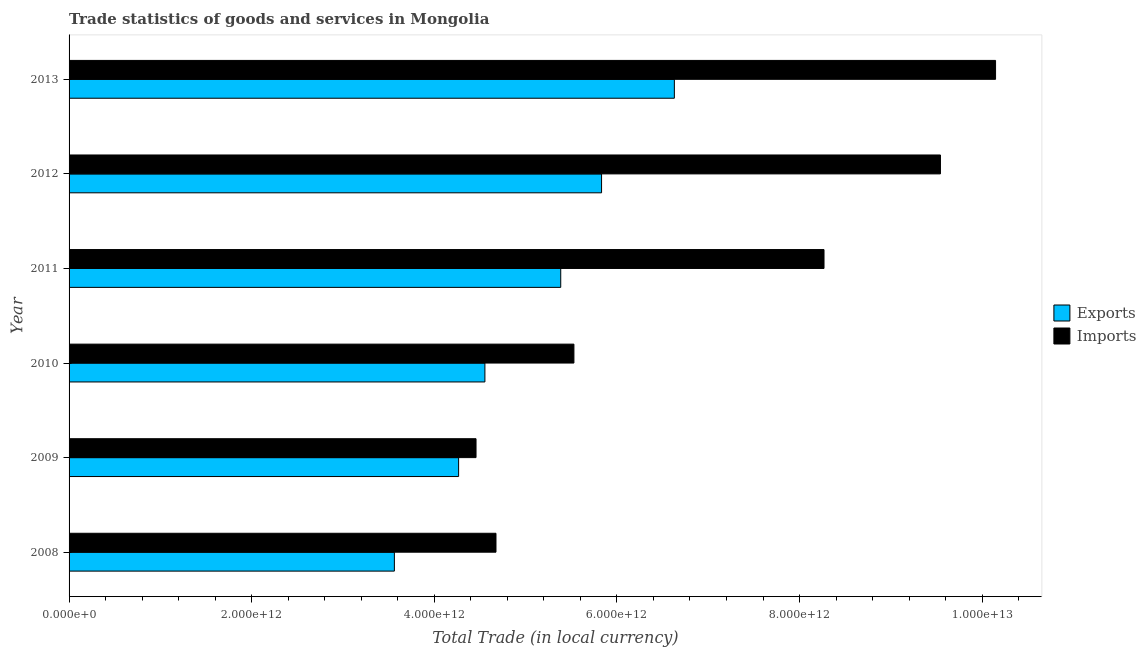How many different coloured bars are there?
Your response must be concise. 2. Are the number of bars on each tick of the Y-axis equal?
Provide a short and direct response. Yes. How many bars are there on the 1st tick from the bottom?
Ensure brevity in your answer.  2. What is the label of the 1st group of bars from the top?
Give a very brief answer. 2013. In how many cases, is the number of bars for a given year not equal to the number of legend labels?
Your response must be concise. 0. What is the imports of goods and services in 2013?
Offer a very short reply. 1.01e+13. Across all years, what is the maximum export of goods and services?
Your response must be concise. 6.63e+12. Across all years, what is the minimum export of goods and services?
Your answer should be very brief. 3.56e+12. In which year was the export of goods and services maximum?
Provide a short and direct response. 2013. In which year was the imports of goods and services minimum?
Give a very brief answer. 2009. What is the total export of goods and services in the graph?
Offer a very short reply. 3.02e+13. What is the difference between the export of goods and services in 2010 and that in 2011?
Provide a short and direct response. -8.30e+11. What is the difference between the export of goods and services in 2013 and the imports of goods and services in 2012?
Ensure brevity in your answer.  -2.91e+12. What is the average imports of goods and services per year?
Provide a succinct answer. 7.10e+12. In the year 2009, what is the difference between the export of goods and services and imports of goods and services?
Provide a short and direct response. -1.91e+11. What is the ratio of the export of goods and services in 2008 to that in 2013?
Your answer should be compact. 0.54. Is the difference between the export of goods and services in 2009 and 2012 greater than the difference between the imports of goods and services in 2009 and 2012?
Your response must be concise. Yes. What is the difference between the highest and the second highest export of goods and services?
Your response must be concise. 7.97e+11. What is the difference between the highest and the lowest export of goods and services?
Your response must be concise. 3.07e+12. Is the sum of the imports of goods and services in 2012 and 2013 greater than the maximum export of goods and services across all years?
Offer a very short reply. Yes. What does the 1st bar from the top in 2009 represents?
Offer a terse response. Imports. What does the 2nd bar from the bottom in 2013 represents?
Give a very brief answer. Imports. How many bars are there?
Provide a short and direct response. 12. Are all the bars in the graph horizontal?
Offer a very short reply. Yes. How many years are there in the graph?
Your answer should be very brief. 6. What is the difference between two consecutive major ticks on the X-axis?
Ensure brevity in your answer.  2.00e+12. Does the graph contain grids?
Give a very brief answer. No. Where does the legend appear in the graph?
Make the answer very short. Center right. How many legend labels are there?
Provide a short and direct response. 2. How are the legend labels stacked?
Your answer should be compact. Vertical. What is the title of the graph?
Your response must be concise. Trade statistics of goods and services in Mongolia. What is the label or title of the X-axis?
Ensure brevity in your answer.  Total Trade (in local currency). What is the label or title of the Y-axis?
Give a very brief answer. Year. What is the Total Trade (in local currency) in Exports in 2008?
Offer a terse response. 3.56e+12. What is the Total Trade (in local currency) of Imports in 2008?
Offer a very short reply. 4.68e+12. What is the Total Trade (in local currency) in Exports in 2009?
Your answer should be very brief. 4.27e+12. What is the Total Trade (in local currency) in Imports in 2009?
Keep it short and to the point. 4.46e+12. What is the Total Trade (in local currency) in Exports in 2010?
Offer a terse response. 4.55e+12. What is the Total Trade (in local currency) in Imports in 2010?
Provide a short and direct response. 5.53e+12. What is the Total Trade (in local currency) in Exports in 2011?
Offer a terse response. 5.38e+12. What is the Total Trade (in local currency) of Imports in 2011?
Your answer should be compact. 8.27e+12. What is the Total Trade (in local currency) in Exports in 2012?
Offer a very short reply. 5.83e+12. What is the Total Trade (in local currency) of Imports in 2012?
Your response must be concise. 9.54e+12. What is the Total Trade (in local currency) in Exports in 2013?
Make the answer very short. 6.63e+12. What is the Total Trade (in local currency) of Imports in 2013?
Give a very brief answer. 1.01e+13. Across all years, what is the maximum Total Trade (in local currency) of Exports?
Your response must be concise. 6.63e+12. Across all years, what is the maximum Total Trade (in local currency) in Imports?
Make the answer very short. 1.01e+13. Across all years, what is the minimum Total Trade (in local currency) in Exports?
Offer a very short reply. 3.56e+12. Across all years, what is the minimum Total Trade (in local currency) in Imports?
Offer a terse response. 4.46e+12. What is the total Total Trade (in local currency) in Exports in the graph?
Provide a succinct answer. 3.02e+13. What is the total Total Trade (in local currency) of Imports in the graph?
Your answer should be compact. 4.26e+13. What is the difference between the Total Trade (in local currency) in Exports in 2008 and that in 2009?
Your answer should be very brief. -7.04e+11. What is the difference between the Total Trade (in local currency) of Imports in 2008 and that in 2009?
Provide a short and direct response. 2.19e+11. What is the difference between the Total Trade (in local currency) of Exports in 2008 and that in 2010?
Give a very brief answer. -9.92e+11. What is the difference between the Total Trade (in local currency) of Imports in 2008 and that in 2010?
Keep it short and to the point. -8.53e+11. What is the difference between the Total Trade (in local currency) in Exports in 2008 and that in 2011?
Your response must be concise. -1.82e+12. What is the difference between the Total Trade (in local currency) of Imports in 2008 and that in 2011?
Keep it short and to the point. -3.59e+12. What is the difference between the Total Trade (in local currency) of Exports in 2008 and that in 2012?
Give a very brief answer. -2.27e+12. What is the difference between the Total Trade (in local currency) of Imports in 2008 and that in 2012?
Keep it short and to the point. -4.87e+12. What is the difference between the Total Trade (in local currency) in Exports in 2008 and that in 2013?
Offer a terse response. -3.07e+12. What is the difference between the Total Trade (in local currency) of Imports in 2008 and that in 2013?
Keep it short and to the point. -5.47e+12. What is the difference between the Total Trade (in local currency) in Exports in 2009 and that in 2010?
Provide a short and direct response. -2.88e+11. What is the difference between the Total Trade (in local currency) in Imports in 2009 and that in 2010?
Offer a very short reply. -1.07e+12. What is the difference between the Total Trade (in local currency) of Exports in 2009 and that in 2011?
Make the answer very short. -1.12e+12. What is the difference between the Total Trade (in local currency) of Imports in 2009 and that in 2011?
Provide a short and direct response. -3.81e+12. What is the difference between the Total Trade (in local currency) of Exports in 2009 and that in 2012?
Give a very brief answer. -1.57e+12. What is the difference between the Total Trade (in local currency) in Imports in 2009 and that in 2012?
Your response must be concise. -5.09e+12. What is the difference between the Total Trade (in local currency) of Exports in 2009 and that in 2013?
Ensure brevity in your answer.  -2.36e+12. What is the difference between the Total Trade (in local currency) of Imports in 2009 and that in 2013?
Provide a succinct answer. -5.69e+12. What is the difference between the Total Trade (in local currency) of Exports in 2010 and that in 2011?
Offer a very short reply. -8.30e+11. What is the difference between the Total Trade (in local currency) in Imports in 2010 and that in 2011?
Provide a succinct answer. -2.74e+12. What is the difference between the Total Trade (in local currency) of Exports in 2010 and that in 2012?
Your response must be concise. -1.28e+12. What is the difference between the Total Trade (in local currency) in Imports in 2010 and that in 2012?
Make the answer very short. -4.01e+12. What is the difference between the Total Trade (in local currency) of Exports in 2010 and that in 2013?
Your answer should be very brief. -2.07e+12. What is the difference between the Total Trade (in local currency) in Imports in 2010 and that in 2013?
Offer a very short reply. -4.62e+12. What is the difference between the Total Trade (in local currency) in Exports in 2011 and that in 2012?
Ensure brevity in your answer.  -4.47e+11. What is the difference between the Total Trade (in local currency) of Imports in 2011 and that in 2012?
Provide a succinct answer. -1.28e+12. What is the difference between the Total Trade (in local currency) of Exports in 2011 and that in 2013?
Your answer should be very brief. -1.24e+12. What is the difference between the Total Trade (in local currency) in Imports in 2011 and that in 2013?
Keep it short and to the point. -1.88e+12. What is the difference between the Total Trade (in local currency) of Exports in 2012 and that in 2013?
Your answer should be compact. -7.97e+11. What is the difference between the Total Trade (in local currency) in Imports in 2012 and that in 2013?
Your answer should be compact. -6.03e+11. What is the difference between the Total Trade (in local currency) of Exports in 2008 and the Total Trade (in local currency) of Imports in 2009?
Make the answer very short. -8.94e+11. What is the difference between the Total Trade (in local currency) in Exports in 2008 and the Total Trade (in local currency) in Imports in 2010?
Ensure brevity in your answer.  -1.97e+12. What is the difference between the Total Trade (in local currency) in Exports in 2008 and the Total Trade (in local currency) in Imports in 2011?
Ensure brevity in your answer.  -4.71e+12. What is the difference between the Total Trade (in local currency) of Exports in 2008 and the Total Trade (in local currency) of Imports in 2012?
Offer a terse response. -5.98e+12. What is the difference between the Total Trade (in local currency) in Exports in 2008 and the Total Trade (in local currency) in Imports in 2013?
Ensure brevity in your answer.  -6.58e+12. What is the difference between the Total Trade (in local currency) of Exports in 2009 and the Total Trade (in local currency) of Imports in 2010?
Ensure brevity in your answer.  -1.26e+12. What is the difference between the Total Trade (in local currency) in Exports in 2009 and the Total Trade (in local currency) in Imports in 2011?
Ensure brevity in your answer.  -4.00e+12. What is the difference between the Total Trade (in local currency) in Exports in 2009 and the Total Trade (in local currency) in Imports in 2012?
Provide a succinct answer. -5.28e+12. What is the difference between the Total Trade (in local currency) in Exports in 2009 and the Total Trade (in local currency) in Imports in 2013?
Your answer should be compact. -5.88e+12. What is the difference between the Total Trade (in local currency) in Exports in 2010 and the Total Trade (in local currency) in Imports in 2011?
Offer a terse response. -3.71e+12. What is the difference between the Total Trade (in local currency) of Exports in 2010 and the Total Trade (in local currency) of Imports in 2012?
Give a very brief answer. -4.99e+12. What is the difference between the Total Trade (in local currency) of Exports in 2010 and the Total Trade (in local currency) of Imports in 2013?
Provide a succinct answer. -5.59e+12. What is the difference between the Total Trade (in local currency) of Exports in 2011 and the Total Trade (in local currency) of Imports in 2012?
Provide a succinct answer. -4.16e+12. What is the difference between the Total Trade (in local currency) of Exports in 2011 and the Total Trade (in local currency) of Imports in 2013?
Give a very brief answer. -4.76e+12. What is the difference between the Total Trade (in local currency) of Exports in 2012 and the Total Trade (in local currency) of Imports in 2013?
Ensure brevity in your answer.  -4.32e+12. What is the average Total Trade (in local currency) of Exports per year?
Offer a terse response. 5.04e+12. What is the average Total Trade (in local currency) in Imports per year?
Your response must be concise. 7.10e+12. In the year 2008, what is the difference between the Total Trade (in local currency) of Exports and Total Trade (in local currency) of Imports?
Your answer should be compact. -1.11e+12. In the year 2009, what is the difference between the Total Trade (in local currency) in Exports and Total Trade (in local currency) in Imports?
Your answer should be very brief. -1.91e+11. In the year 2010, what is the difference between the Total Trade (in local currency) of Exports and Total Trade (in local currency) of Imports?
Make the answer very short. -9.75e+11. In the year 2011, what is the difference between the Total Trade (in local currency) of Exports and Total Trade (in local currency) of Imports?
Offer a very short reply. -2.88e+12. In the year 2012, what is the difference between the Total Trade (in local currency) in Exports and Total Trade (in local currency) in Imports?
Provide a short and direct response. -3.71e+12. In the year 2013, what is the difference between the Total Trade (in local currency) in Exports and Total Trade (in local currency) in Imports?
Ensure brevity in your answer.  -3.52e+12. What is the ratio of the Total Trade (in local currency) of Exports in 2008 to that in 2009?
Provide a short and direct response. 0.84. What is the ratio of the Total Trade (in local currency) in Imports in 2008 to that in 2009?
Offer a very short reply. 1.05. What is the ratio of the Total Trade (in local currency) in Exports in 2008 to that in 2010?
Your response must be concise. 0.78. What is the ratio of the Total Trade (in local currency) of Imports in 2008 to that in 2010?
Offer a terse response. 0.85. What is the ratio of the Total Trade (in local currency) in Exports in 2008 to that in 2011?
Ensure brevity in your answer.  0.66. What is the ratio of the Total Trade (in local currency) in Imports in 2008 to that in 2011?
Your answer should be compact. 0.57. What is the ratio of the Total Trade (in local currency) of Exports in 2008 to that in 2012?
Provide a short and direct response. 0.61. What is the ratio of the Total Trade (in local currency) of Imports in 2008 to that in 2012?
Make the answer very short. 0.49. What is the ratio of the Total Trade (in local currency) in Exports in 2008 to that in 2013?
Offer a very short reply. 0.54. What is the ratio of the Total Trade (in local currency) of Imports in 2008 to that in 2013?
Your answer should be very brief. 0.46. What is the ratio of the Total Trade (in local currency) in Exports in 2009 to that in 2010?
Your answer should be very brief. 0.94. What is the ratio of the Total Trade (in local currency) in Imports in 2009 to that in 2010?
Your answer should be very brief. 0.81. What is the ratio of the Total Trade (in local currency) of Exports in 2009 to that in 2011?
Give a very brief answer. 0.79. What is the ratio of the Total Trade (in local currency) in Imports in 2009 to that in 2011?
Make the answer very short. 0.54. What is the ratio of the Total Trade (in local currency) in Exports in 2009 to that in 2012?
Make the answer very short. 0.73. What is the ratio of the Total Trade (in local currency) in Imports in 2009 to that in 2012?
Give a very brief answer. 0.47. What is the ratio of the Total Trade (in local currency) in Exports in 2009 to that in 2013?
Provide a short and direct response. 0.64. What is the ratio of the Total Trade (in local currency) in Imports in 2009 to that in 2013?
Provide a succinct answer. 0.44. What is the ratio of the Total Trade (in local currency) in Exports in 2010 to that in 2011?
Offer a terse response. 0.85. What is the ratio of the Total Trade (in local currency) of Imports in 2010 to that in 2011?
Offer a terse response. 0.67. What is the ratio of the Total Trade (in local currency) in Exports in 2010 to that in 2012?
Your answer should be very brief. 0.78. What is the ratio of the Total Trade (in local currency) in Imports in 2010 to that in 2012?
Ensure brevity in your answer.  0.58. What is the ratio of the Total Trade (in local currency) in Exports in 2010 to that in 2013?
Keep it short and to the point. 0.69. What is the ratio of the Total Trade (in local currency) in Imports in 2010 to that in 2013?
Your answer should be compact. 0.54. What is the ratio of the Total Trade (in local currency) in Exports in 2011 to that in 2012?
Give a very brief answer. 0.92. What is the ratio of the Total Trade (in local currency) in Imports in 2011 to that in 2012?
Provide a short and direct response. 0.87. What is the ratio of the Total Trade (in local currency) in Exports in 2011 to that in 2013?
Provide a succinct answer. 0.81. What is the ratio of the Total Trade (in local currency) in Imports in 2011 to that in 2013?
Make the answer very short. 0.81. What is the ratio of the Total Trade (in local currency) of Exports in 2012 to that in 2013?
Provide a short and direct response. 0.88. What is the ratio of the Total Trade (in local currency) in Imports in 2012 to that in 2013?
Offer a very short reply. 0.94. What is the difference between the highest and the second highest Total Trade (in local currency) of Exports?
Keep it short and to the point. 7.97e+11. What is the difference between the highest and the second highest Total Trade (in local currency) of Imports?
Make the answer very short. 6.03e+11. What is the difference between the highest and the lowest Total Trade (in local currency) in Exports?
Offer a terse response. 3.07e+12. What is the difference between the highest and the lowest Total Trade (in local currency) in Imports?
Provide a succinct answer. 5.69e+12. 